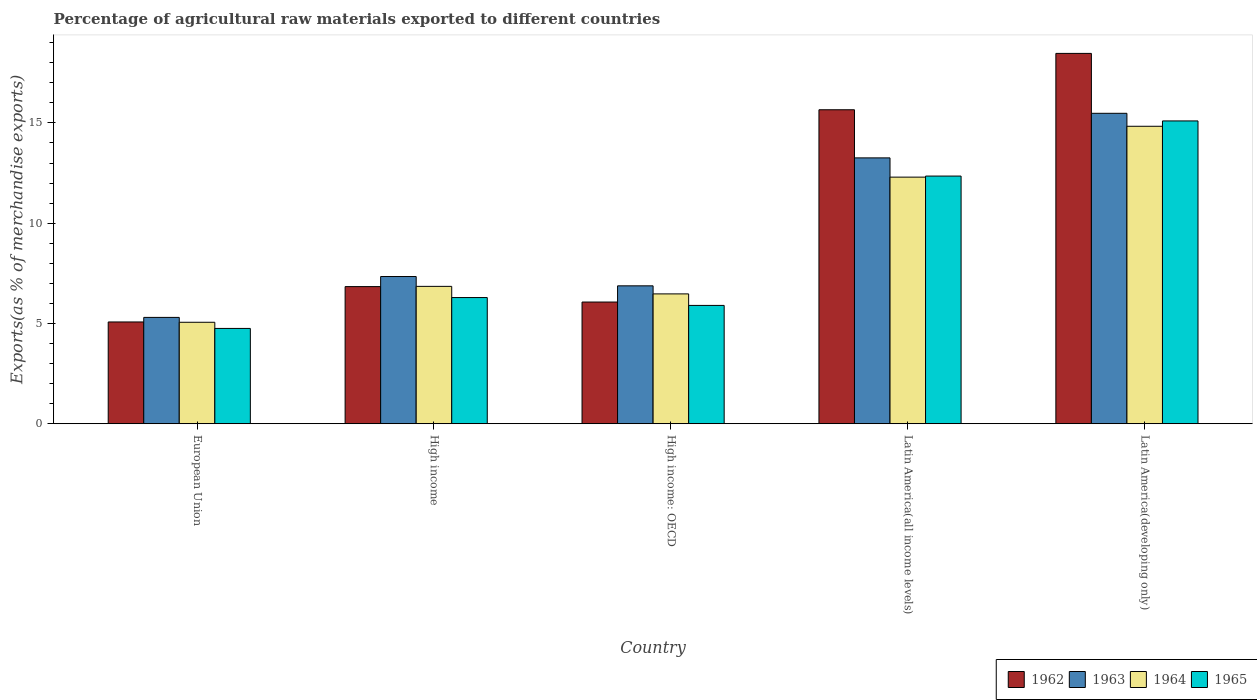How many different coloured bars are there?
Give a very brief answer. 4. Are the number of bars on each tick of the X-axis equal?
Provide a succinct answer. Yes. How many bars are there on the 3rd tick from the left?
Keep it short and to the point. 4. How many bars are there on the 5th tick from the right?
Your response must be concise. 4. What is the label of the 4th group of bars from the left?
Offer a very short reply. Latin America(all income levels). In how many cases, is the number of bars for a given country not equal to the number of legend labels?
Make the answer very short. 0. What is the percentage of exports to different countries in 1965 in European Union?
Keep it short and to the point. 4.75. Across all countries, what is the maximum percentage of exports to different countries in 1962?
Give a very brief answer. 18.47. Across all countries, what is the minimum percentage of exports to different countries in 1964?
Give a very brief answer. 5.06. In which country was the percentage of exports to different countries in 1964 maximum?
Offer a terse response. Latin America(developing only). In which country was the percentage of exports to different countries in 1965 minimum?
Your response must be concise. European Union. What is the total percentage of exports to different countries in 1964 in the graph?
Provide a short and direct response. 45.52. What is the difference between the percentage of exports to different countries in 1962 in European Union and that in Latin America(all income levels)?
Keep it short and to the point. -10.58. What is the difference between the percentage of exports to different countries in 1963 in Latin America(developing only) and the percentage of exports to different countries in 1965 in European Union?
Your answer should be very brief. 10.73. What is the average percentage of exports to different countries in 1963 per country?
Your answer should be very brief. 9.65. What is the difference between the percentage of exports to different countries of/in 1962 and percentage of exports to different countries of/in 1964 in High income?
Provide a succinct answer. -0.01. What is the ratio of the percentage of exports to different countries in 1963 in European Union to that in Latin America(all income levels)?
Provide a short and direct response. 0.4. Is the difference between the percentage of exports to different countries in 1962 in European Union and Latin America(developing only) greater than the difference between the percentage of exports to different countries in 1964 in European Union and Latin America(developing only)?
Your answer should be very brief. No. What is the difference between the highest and the second highest percentage of exports to different countries in 1965?
Ensure brevity in your answer.  6.06. What is the difference between the highest and the lowest percentage of exports to different countries in 1962?
Give a very brief answer. 13.39. In how many countries, is the percentage of exports to different countries in 1962 greater than the average percentage of exports to different countries in 1962 taken over all countries?
Ensure brevity in your answer.  2. Is the sum of the percentage of exports to different countries in 1965 in High income and Latin America(developing only) greater than the maximum percentage of exports to different countries in 1964 across all countries?
Provide a short and direct response. Yes. What does the 3rd bar from the left in High income: OECD represents?
Provide a succinct answer. 1964. What does the 2nd bar from the right in Latin America(developing only) represents?
Provide a succinct answer. 1964. How many bars are there?
Provide a short and direct response. 20. Are all the bars in the graph horizontal?
Your answer should be very brief. No. How many countries are there in the graph?
Your response must be concise. 5. Does the graph contain grids?
Your answer should be very brief. No. Where does the legend appear in the graph?
Ensure brevity in your answer.  Bottom right. What is the title of the graph?
Your answer should be very brief. Percentage of agricultural raw materials exported to different countries. What is the label or title of the Y-axis?
Give a very brief answer. Exports(as % of merchandise exports). What is the Exports(as % of merchandise exports) in 1962 in European Union?
Provide a succinct answer. 5.08. What is the Exports(as % of merchandise exports) of 1963 in European Union?
Offer a very short reply. 5.3. What is the Exports(as % of merchandise exports) in 1964 in European Union?
Provide a short and direct response. 5.06. What is the Exports(as % of merchandise exports) in 1965 in European Union?
Your answer should be very brief. 4.75. What is the Exports(as % of merchandise exports) of 1962 in High income?
Give a very brief answer. 6.84. What is the Exports(as % of merchandise exports) of 1963 in High income?
Provide a succinct answer. 7.34. What is the Exports(as % of merchandise exports) in 1964 in High income?
Keep it short and to the point. 6.85. What is the Exports(as % of merchandise exports) in 1965 in High income?
Ensure brevity in your answer.  6.29. What is the Exports(as % of merchandise exports) in 1962 in High income: OECD?
Your response must be concise. 6.07. What is the Exports(as % of merchandise exports) of 1963 in High income: OECD?
Provide a succinct answer. 6.88. What is the Exports(as % of merchandise exports) of 1964 in High income: OECD?
Make the answer very short. 6.47. What is the Exports(as % of merchandise exports) of 1965 in High income: OECD?
Offer a very short reply. 5.9. What is the Exports(as % of merchandise exports) in 1962 in Latin America(all income levels)?
Make the answer very short. 15.66. What is the Exports(as % of merchandise exports) of 1963 in Latin America(all income levels)?
Make the answer very short. 13.26. What is the Exports(as % of merchandise exports) of 1964 in Latin America(all income levels)?
Offer a very short reply. 12.3. What is the Exports(as % of merchandise exports) in 1965 in Latin America(all income levels)?
Keep it short and to the point. 12.35. What is the Exports(as % of merchandise exports) in 1962 in Latin America(developing only)?
Give a very brief answer. 18.47. What is the Exports(as % of merchandise exports) of 1963 in Latin America(developing only)?
Give a very brief answer. 15.48. What is the Exports(as % of merchandise exports) of 1964 in Latin America(developing only)?
Give a very brief answer. 14.83. What is the Exports(as % of merchandise exports) in 1965 in Latin America(developing only)?
Offer a terse response. 15.1. Across all countries, what is the maximum Exports(as % of merchandise exports) of 1962?
Make the answer very short. 18.47. Across all countries, what is the maximum Exports(as % of merchandise exports) in 1963?
Provide a succinct answer. 15.48. Across all countries, what is the maximum Exports(as % of merchandise exports) in 1964?
Your answer should be very brief. 14.83. Across all countries, what is the maximum Exports(as % of merchandise exports) in 1965?
Ensure brevity in your answer.  15.1. Across all countries, what is the minimum Exports(as % of merchandise exports) of 1962?
Give a very brief answer. 5.08. Across all countries, what is the minimum Exports(as % of merchandise exports) of 1963?
Provide a succinct answer. 5.3. Across all countries, what is the minimum Exports(as % of merchandise exports) of 1964?
Offer a terse response. 5.06. Across all countries, what is the minimum Exports(as % of merchandise exports) in 1965?
Your answer should be compact. 4.75. What is the total Exports(as % of merchandise exports) in 1962 in the graph?
Offer a very short reply. 52.11. What is the total Exports(as % of merchandise exports) of 1963 in the graph?
Provide a succinct answer. 48.26. What is the total Exports(as % of merchandise exports) of 1964 in the graph?
Your answer should be compact. 45.52. What is the total Exports(as % of merchandise exports) of 1965 in the graph?
Give a very brief answer. 44.4. What is the difference between the Exports(as % of merchandise exports) of 1962 in European Union and that in High income?
Ensure brevity in your answer.  -1.76. What is the difference between the Exports(as % of merchandise exports) of 1963 in European Union and that in High income?
Offer a very short reply. -2.04. What is the difference between the Exports(as % of merchandise exports) in 1964 in European Union and that in High income?
Your answer should be very brief. -1.79. What is the difference between the Exports(as % of merchandise exports) of 1965 in European Union and that in High income?
Give a very brief answer. -1.54. What is the difference between the Exports(as % of merchandise exports) of 1962 in European Union and that in High income: OECD?
Give a very brief answer. -0.99. What is the difference between the Exports(as % of merchandise exports) in 1963 in European Union and that in High income: OECD?
Keep it short and to the point. -1.57. What is the difference between the Exports(as % of merchandise exports) of 1964 in European Union and that in High income: OECD?
Keep it short and to the point. -1.41. What is the difference between the Exports(as % of merchandise exports) in 1965 in European Union and that in High income: OECD?
Offer a very short reply. -1.15. What is the difference between the Exports(as % of merchandise exports) of 1962 in European Union and that in Latin America(all income levels)?
Provide a short and direct response. -10.58. What is the difference between the Exports(as % of merchandise exports) in 1963 in European Union and that in Latin America(all income levels)?
Ensure brevity in your answer.  -7.95. What is the difference between the Exports(as % of merchandise exports) of 1964 in European Union and that in Latin America(all income levels)?
Provide a succinct answer. -7.24. What is the difference between the Exports(as % of merchandise exports) in 1965 in European Union and that in Latin America(all income levels)?
Give a very brief answer. -7.6. What is the difference between the Exports(as % of merchandise exports) in 1962 in European Union and that in Latin America(developing only)?
Provide a short and direct response. -13.39. What is the difference between the Exports(as % of merchandise exports) in 1963 in European Union and that in Latin America(developing only)?
Make the answer very short. -10.18. What is the difference between the Exports(as % of merchandise exports) of 1964 in European Union and that in Latin America(developing only)?
Your answer should be compact. -9.77. What is the difference between the Exports(as % of merchandise exports) of 1965 in European Union and that in Latin America(developing only)?
Make the answer very short. -10.35. What is the difference between the Exports(as % of merchandise exports) in 1962 in High income and that in High income: OECD?
Offer a terse response. 0.77. What is the difference between the Exports(as % of merchandise exports) in 1963 in High income and that in High income: OECD?
Your answer should be very brief. 0.46. What is the difference between the Exports(as % of merchandise exports) of 1964 in High income and that in High income: OECD?
Your answer should be compact. 0.38. What is the difference between the Exports(as % of merchandise exports) in 1965 in High income and that in High income: OECD?
Provide a succinct answer. 0.39. What is the difference between the Exports(as % of merchandise exports) of 1962 in High income and that in Latin America(all income levels)?
Provide a succinct answer. -8.82. What is the difference between the Exports(as % of merchandise exports) of 1963 in High income and that in Latin America(all income levels)?
Your answer should be very brief. -5.92. What is the difference between the Exports(as % of merchandise exports) of 1964 in High income and that in Latin America(all income levels)?
Offer a terse response. -5.45. What is the difference between the Exports(as % of merchandise exports) in 1965 in High income and that in Latin America(all income levels)?
Provide a succinct answer. -6.06. What is the difference between the Exports(as % of merchandise exports) of 1962 in High income and that in Latin America(developing only)?
Ensure brevity in your answer.  -11.63. What is the difference between the Exports(as % of merchandise exports) in 1963 in High income and that in Latin America(developing only)?
Provide a short and direct response. -8.14. What is the difference between the Exports(as % of merchandise exports) of 1964 in High income and that in Latin America(developing only)?
Your answer should be very brief. -7.98. What is the difference between the Exports(as % of merchandise exports) in 1965 in High income and that in Latin America(developing only)?
Ensure brevity in your answer.  -8.81. What is the difference between the Exports(as % of merchandise exports) of 1962 in High income: OECD and that in Latin America(all income levels)?
Offer a very short reply. -9.59. What is the difference between the Exports(as % of merchandise exports) in 1963 in High income: OECD and that in Latin America(all income levels)?
Make the answer very short. -6.38. What is the difference between the Exports(as % of merchandise exports) of 1964 in High income: OECD and that in Latin America(all income levels)?
Give a very brief answer. -5.82. What is the difference between the Exports(as % of merchandise exports) in 1965 in High income: OECD and that in Latin America(all income levels)?
Your answer should be compact. -6.45. What is the difference between the Exports(as % of merchandise exports) of 1962 in High income: OECD and that in Latin America(developing only)?
Your answer should be compact. -12.4. What is the difference between the Exports(as % of merchandise exports) of 1963 in High income: OECD and that in Latin America(developing only)?
Give a very brief answer. -8.6. What is the difference between the Exports(as % of merchandise exports) in 1964 in High income: OECD and that in Latin America(developing only)?
Give a very brief answer. -8.36. What is the difference between the Exports(as % of merchandise exports) of 1965 in High income: OECD and that in Latin America(developing only)?
Keep it short and to the point. -9.2. What is the difference between the Exports(as % of merchandise exports) of 1962 in Latin America(all income levels) and that in Latin America(developing only)?
Keep it short and to the point. -2.81. What is the difference between the Exports(as % of merchandise exports) in 1963 in Latin America(all income levels) and that in Latin America(developing only)?
Your answer should be compact. -2.22. What is the difference between the Exports(as % of merchandise exports) of 1964 in Latin America(all income levels) and that in Latin America(developing only)?
Offer a terse response. -2.54. What is the difference between the Exports(as % of merchandise exports) in 1965 in Latin America(all income levels) and that in Latin America(developing only)?
Provide a succinct answer. -2.75. What is the difference between the Exports(as % of merchandise exports) in 1962 in European Union and the Exports(as % of merchandise exports) in 1963 in High income?
Provide a short and direct response. -2.27. What is the difference between the Exports(as % of merchandise exports) of 1962 in European Union and the Exports(as % of merchandise exports) of 1964 in High income?
Your response must be concise. -1.78. What is the difference between the Exports(as % of merchandise exports) of 1962 in European Union and the Exports(as % of merchandise exports) of 1965 in High income?
Your response must be concise. -1.22. What is the difference between the Exports(as % of merchandise exports) in 1963 in European Union and the Exports(as % of merchandise exports) in 1964 in High income?
Provide a succinct answer. -1.55. What is the difference between the Exports(as % of merchandise exports) of 1963 in European Union and the Exports(as % of merchandise exports) of 1965 in High income?
Offer a terse response. -0.99. What is the difference between the Exports(as % of merchandise exports) of 1964 in European Union and the Exports(as % of merchandise exports) of 1965 in High income?
Give a very brief answer. -1.23. What is the difference between the Exports(as % of merchandise exports) of 1962 in European Union and the Exports(as % of merchandise exports) of 1963 in High income: OECD?
Your answer should be very brief. -1.8. What is the difference between the Exports(as % of merchandise exports) of 1962 in European Union and the Exports(as % of merchandise exports) of 1964 in High income: OECD?
Your response must be concise. -1.4. What is the difference between the Exports(as % of merchandise exports) in 1962 in European Union and the Exports(as % of merchandise exports) in 1965 in High income: OECD?
Make the answer very short. -0.83. What is the difference between the Exports(as % of merchandise exports) of 1963 in European Union and the Exports(as % of merchandise exports) of 1964 in High income: OECD?
Your response must be concise. -1.17. What is the difference between the Exports(as % of merchandise exports) in 1963 in European Union and the Exports(as % of merchandise exports) in 1965 in High income: OECD?
Ensure brevity in your answer.  -0.6. What is the difference between the Exports(as % of merchandise exports) in 1964 in European Union and the Exports(as % of merchandise exports) in 1965 in High income: OECD?
Your answer should be very brief. -0.84. What is the difference between the Exports(as % of merchandise exports) in 1962 in European Union and the Exports(as % of merchandise exports) in 1963 in Latin America(all income levels)?
Your response must be concise. -8.18. What is the difference between the Exports(as % of merchandise exports) of 1962 in European Union and the Exports(as % of merchandise exports) of 1964 in Latin America(all income levels)?
Offer a very short reply. -7.22. What is the difference between the Exports(as % of merchandise exports) of 1962 in European Union and the Exports(as % of merchandise exports) of 1965 in Latin America(all income levels)?
Make the answer very short. -7.28. What is the difference between the Exports(as % of merchandise exports) of 1963 in European Union and the Exports(as % of merchandise exports) of 1964 in Latin America(all income levels)?
Offer a terse response. -7. What is the difference between the Exports(as % of merchandise exports) in 1963 in European Union and the Exports(as % of merchandise exports) in 1965 in Latin America(all income levels)?
Give a very brief answer. -7.05. What is the difference between the Exports(as % of merchandise exports) in 1964 in European Union and the Exports(as % of merchandise exports) in 1965 in Latin America(all income levels)?
Provide a short and direct response. -7.29. What is the difference between the Exports(as % of merchandise exports) in 1962 in European Union and the Exports(as % of merchandise exports) in 1963 in Latin America(developing only)?
Ensure brevity in your answer.  -10.41. What is the difference between the Exports(as % of merchandise exports) of 1962 in European Union and the Exports(as % of merchandise exports) of 1964 in Latin America(developing only)?
Make the answer very short. -9.76. What is the difference between the Exports(as % of merchandise exports) in 1962 in European Union and the Exports(as % of merchandise exports) in 1965 in Latin America(developing only)?
Offer a terse response. -10.02. What is the difference between the Exports(as % of merchandise exports) of 1963 in European Union and the Exports(as % of merchandise exports) of 1964 in Latin America(developing only)?
Provide a succinct answer. -9.53. What is the difference between the Exports(as % of merchandise exports) in 1963 in European Union and the Exports(as % of merchandise exports) in 1965 in Latin America(developing only)?
Offer a terse response. -9.8. What is the difference between the Exports(as % of merchandise exports) of 1964 in European Union and the Exports(as % of merchandise exports) of 1965 in Latin America(developing only)?
Provide a succinct answer. -10.04. What is the difference between the Exports(as % of merchandise exports) in 1962 in High income and the Exports(as % of merchandise exports) in 1963 in High income: OECD?
Give a very brief answer. -0.04. What is the difference between the Exports(as % of merchandise exports) of 1962 in High income and the Exports(as % of merchandise exports) of 1964 in High income: OECD?
Your answer should be compact. 0.36. What is the difference between the Exports(as % of merchandise exports) of 1962 in High income and the Exports(as % of merchandise exports) of 1965 in High income: OECD?
Offer a terse response. 0.94. What is the difference between the Exports(as % of merchandise exports) of 1963 in High income and the Exports(as % of merchandise exports) of 1964 in High income: OECD?
Offer a very short reply. 0.87. What is the difference between the Exports(as % of merchandise exports) of 1963 in High income and the Exports(as % of merchandise exports) of 1965 in High income: OECD?
Provide a short and direct response. 1.44. What is the difference between the Exports(as % of merchandise exports) of 1964 in High income and the Exports(as % of merchandise exports) of 1965 in High income: OECD?
Your response must be concise. 0.95. What is the difference between the Exports(as % of merchandise exports) of 1962 in High income and the Exports(as % of merchandise exports) of 1963 in Latin America(all income levels)?
Make the answer very short. -6.42. What is the difference between the Exports(as % of merchandise exports) in 1962 in High income and the Exports(as % of merchandise exports) in 1964 in Latin America(all income levels)?
Give a very brief answer. -5.46. What is the difference between the Exports(as % of merchandise exports) in 1962 in High income and the Exports(as % of merchandise exports) in 1965 in Latin America(all income levels)?
Provide a short and direct response. -5.51. What is the difference between the Exports(as % of merchandise exports) of 1963 in High income and the Exports(as % of merchandise exports) of 1964 in Latin America(all income levels)?
Make the answer very short. -4.96. What is the difference between the Exports(as % of merchandise exports) of 1963 in High income and the Exports(as % of merchandise exports) of 1965 in Latin America(all income levels)?
Ensure brevity in your answer.  -5.01. What is the difference between the Exports(as % of merchandise exports) in 1962 in High income and the Exports(as % of merchandise exports) in 1963 in Latin America(developing only)?
Ensure brevity in your answer.  -8.64. What is the difference between the Exports(as % of merchandise exports) of 1962 in High income and the Exports(as % of merchandise exports) of 1964 in Latin America(developing only)?
Make the answer very short. -8. What is the difference between the Exports(as % of merchandise exports) in 1962 in High income and the Exports(as % of merchandise exports) in 1965 in Latin America(developing only)?
Your answer should be very brief. -8.26. What is the difference between the Exports(as % of merchandise exports) of 1963 in High income and the Exports(as % of merchandise exports) of 1964 in Latin America(developing only)?
Your answer should be compact. -7.49. What is the difference between the Exports(as % of merchandise exports) of 1963 in High income and the Exports(as % of merchandise exports) of 1965 in Latin America(developing only)?
Provide a succinct answer. -7.76. What is the difference between the Exports(as % of merchandise exports) in 1964 in High income and the Exports(as % of merchandise exports) in 1965 in Latin America(developing only)?
Ensure brevity in your answer.  -8.25. What is the difference between the Exports(as % of merchandise exports) in 1962 in High income: OECD and the Exports(as % of merchandise exports) in 1963 in Latin America(all income levels)?
Offer a very short reply. -7.19. What is the difference between the Exports(as % of merchandise exports) in 1962 in High income: OECD and the Exports(as % of merchandise exports) in 1964 in Latin America(all income levels)?
Provide a succinct answer. -6.23. What is the difference between the Exports(as % of merchandise exports) of 1962 in High income: OECD and the Exports(as % of merchandise exports) of 1965 in Latin America(all income levels)?
Your response must be concise. -6.28. What is the difference between the Exports(as % of merchandise exports) of 1963 in High income: OECD and the Exports(as % of merchandise exports) of 1964 in Latin America(all income levels)?
Provide a succinct answer. -5.42. What is the difference between the Exports(as % of merchandise exports) in 1963 in High income: OECD and the Exports(as % of merchandise exports) in 1965 in Latin America(all income levels)?
Ensure brevity in your answer.  -5.47. What is the difference between the Exports(as % of merchandise exports) in 1964 in High income: OECD and the Exports(as % of merchandise exports) in 1965 in Latin America(all income levels)?
Your answer should be very brief. -5.88. What is the difference between the Exports(as % of merchandise exports) of 1962 in High income: OECD and the Exports(as % of merchandise exports) of 1963 in Latin America(developing only)?
Offer a very short reply. -9.41. What is the difference between the Exports(as % of merchandise exports) of 1962 in High income: OECD and the Exports(as % of merchandise exports) of 1964 in Latin America(developing only)?
Ensure brevity in your answer.  -8.76. What is the difference between the Exports(as % of merchandise exports) of 1962 in High income: OECD and the Exports(as % of merchandise exports) of 1965 in Latin America(developing only)?
Your response must be concise. -9.03. What is the difference between the Exports(as % of merchandise exports) in 1963 in High income: OECD and the Exports(as % of merchandise exports) in 1964 in Latin America(developing only)?
Your answer should be very brief. -7.96. What is the difference between the Exports(as % of merchandise exports) of 1963 in High income: OECD and the Exports(as % of merchandise exports) of 1965 in Latin America(developing only)?
Your answer should be compact. -8.22. What is the difference between the Exports(as % of merchandise exports) of 1964 in High income: OECD and the Exports(as % of merchandise exports) of 1965 in Latin America(developing only)?
Keep it short and to the point. -8.63. What is the difference between the Exports(as % of merchandise exports) of 1962 in Latin America(all income levels) and the Exports(as % of merchandise exports) of 1963 in Latin America(developing only)?
Provide a succinct answer. 0.18. What is the difference between the Exports(as % of merchandise exports) in 1962 in Latin America(all income levels) and the Exports(as % of merchandise exports) in 1964 in Latin America(developing only)?
Make the answer very short. 0.82. What is the difference between the Exports(as % of merchandise exports) of 1962 in Latin America(all income levels) and the Exports(as % of merchandise exports) of 1965 in Latin America(developing only)?
Your answer should be compact. 0.56. What is the difference between the Exports(as % of merchandise exports) of 1963 in Latin America(all income levels) and the Exports(as % of merchandise exports) of 1964 in Latin America(developing only)?
Make the answer very short. -1.58. What is the difference between the Exports(as % of merchandise exports) in 1963 in Latin America(all income levels) and the Exports(as % of merchandise exports) in 1965 in Latin America(developing only)?
Your answer should be very brief. -1.84. What is the difference between the Exports(as % of merchandise exports) of 1964 in Latin America(all income levels) and the Exports(as % of merchandise exports) of 1965 in Latin America(developing only)?
Offer a terse response. -2.8. What is the average Exports(as % of merchandise exports) of 1962 per country?
Offer a very short reply. 10.42. What is the average Exports(as % of merchandise exports) of 1963 per country?
Provide a succinct answer. 9.65. What is the average Exports(as % of merchandise exports) in 1964 per country?
Provide a short and direct response. 9.1. What is the average Exports(as % of merchandise exports) of 1965 per country?
Ensure brevity in your answer.  8.88. What is the difference between the Exports(as % of merchandise exports) of 1962 and Exports(as % of merchandise exports) of 1963 in European Union?
Offer a very short reply. -0.23. What is the difference between the Exports(as % of merchandise exports) of 1962 and Exports(as % of merchandise exports) of 1964 in European Union?
Ensure brevity in your answer.  0.02. What is the difference between the Exports(as % of merchandise exports) in 1962 and Exports(as % of merchandise exports) in 1965 in European Union?
Your answer should be compact. 0.32. What is the difference between the Exports(as % of merchandise exports) in 1963 and Exports(as % of merchandise exports) in 1964 in European Union?
Ensure brevity in your answer.  0.24. What is the difference between the Exports(as % of merchandise exports) in 1963 and Exports(as % of merchandise exports) in 1965 in European Union?
Give a very brief answer. 0.55. What is the difference between the Exports(as % of merchandise exports) of 1964 and Exports(as % of merchandise exports) of 1965 in European Union?
Your answer should be very brief. 0.31. What is the difference between the Exports(as % of merchandise exports) in 1962 and Exports(as % of merchandise exports) in 1963 in High income?
Your answer should be compact. -0.5. What is the difference between the Exports(as % of merchandise exports) in 1962 and Exports(as % of merchandise exports) in 1964 in High income?
Keep it short and to the point. -0.01. What is the difference between the Exports(as % of merchandise exports) of 1962 and Exports(as % of merchandise exports) of 1965 in High income?
Ensure brevity in your answer.  0.55. What is the difference between the Exports(as % of merchandise exports) in 1963 and Exports(as % of merchandise exports) in 1964 in High income?
Offer a very short reply. 0.49. What is the difference between the Exports(as % of merchandise exports) in 1963 and Exports(as % of merchandise exports) in 1965 in High income?
Keep it short and to the point. 1.05. What is the difference between the Exports(as % of merchandise exports) of 1964 and Exports(as % of merchandise exports) of 1965 in High income?
Keep it short and to the point. 0.56. What is the difference between the Exports(as % of merchandise exports) of 1962 and Exports(as % of merchandise exports) of 1963 in High income: OECD?
Provide a succinct answer. -0.81. What is the difference between the Exports(as % of merchandise exports) in 1962 and Exports(as % of merchandise exports) in 1964 in High income: OECD?
Your answer should be compact. -0.41. What is the difference between the Exports(as % of merchandise exports) in 1962 and Exports(as % of merchandise exports) in 1965 in High income: OECD?
Offer a very short reply. 0.17. What is the difference between the Exports(as % of merchandise exports) of 1963 and Exports(as % of merchandise exports) of 1964 in High income: OECD?
Your answer should be very brief. 0.4. What is the difference between the Exports(as % of merchandise exports) of 1963 and Exports(as % of merchandise exports) of 1965 in High income: OECD?
Offer a very short reply. 0.98. What is the difference between the Exports(as % of merchandise exports) in 1964 and Exports(as % of merchandise exports) in 1965 in High income: OECD?
Keep it short and to the point. 0.57. What is the difference between the Exports(as % of merchandise exports) in 1962 and Exports(as % of merchandise exports) in 1963 in Latin America(all income levels)?
Provide a succinct answer. 2.4. What is the difference between the Exports(as % of merchandise exports) of 1962 and Exports(as % of merchandise exports) of 1964 in Latin America(all income levels)?
Offer a terse response. 3.36. What is the difference between the Exports(as % of merchandise exports) in 1962 and Exports(as % of merchandise exports) in 1965 in Latin America(all income levels)?
Ensure brevity in your answer.  3.31. What is the difference between the Exports(as % of merchandise exports) in 1963 and Exports(as % of merchandise exports) in 1964 in Latin America(all income levels)?
Make the answer very short. 0.96. What is the difference between the Exports(as % of merchandise exports) of 1963 and Exports(as % of merchandise exports) of 1965 in Latin America(all income levels)?
Provide a short and direct response. 0.91. What is the difference between the Exports(as % of merchandise exports) in 1964 and Exports(as % of merchandise exports) in 1965 in Latin America(all income levels)?
Your response must be concise. -0.05. What is the difference between the Exports(as % of merchandise exports) in 1962 and Exports(as % of merchandise exports) in 1963 in Latin America(developing only)?
Your answer should be very brief. 2.99. What is the difference between the Exports(as % of merchandise exports) in 1962 and Exports(as % of merchandise exports) in 1964 in Latin America(developing only)?
Your answer should be very brief. 3.63. What is the difference between the Exports(as % of merchandise exports) of 1962 and Exports(as % of merchandise exports) of 1965 in Latin America(developing only)?
Provide a succinct answer. 3.37. What is the difference between the Exports(as % of merchandise exports) in 1963 and Exports(as % of merchandise exports) in 1964 in Latin America(developing only)?
Your response must be concise. 0.65. What is the difference between the Exports(as % of merchandise exports) in 1963 and Exports(as % of merchandise exports) in 1965 in Latin America(developing only)?
Offer a very short reply. 0.38. What is the difference between the Exports(as % of merchandise exports) in 1964 and Exports(as % of merchandise exports) in 1965 in Latin America(developing only)?
Your answer should be compact. -0.27. What is the ratio of the Exports(as % of merchandise exports) in 1962 in European Union to that in High income?
Give a very brief answer. 0.74. What is the ratio of the Exports(as % of merchandise exports) in 1963 in European Union to that in High income?
Provide a succinct answer. 0.72. What is the ratio of the Exports(as % of merchandise exports) of 1964 in European Union to that in High income?
Your answer should be very brief. 0.74. What is the ratio of the Exports(as % of merchandise exports) of 1965 in European Union to that in High income?
Your answer should be very brief. 0.76. What is the ratio of the Exports(as % of merchandise exports) of 1962 in European Union to that in High income: OECD?
Offer a terse response. 0.84. What is the ratio of the Exports(as % of merchandise exports) in 1963 in European Union to that in High income: OECD?
Give a very brief answer. 0.77. What is the ratio of the Exports(as % of merchandise exports) of 1964 in European Union to that in High income: OECD?
Your answer should be very brief. 0.78. What is the ratio of the Exports(as % of merchandise exports) in 1965 in European Union to that in High income: OECD?
Ensure brevity in your answer.  0.81. What is the ratio of the Exports(as % of merchandise exports) in 1962 in European Union to that in Latin America(all income levels)?
Your response must be concise. 0.32. What is the ratio of the Exports(as % of merchandise exports) of 1963 in European Union to that in Latin America(all income levels)?
Offer a very short reply. 0.4. What is the ratio of the Exports(as % of merchandise exports) of 1964 in European Union to that in Latin America(all income levels)?
Offer a terse response. 0.41. What is the ratio of the Exports(as % of merchandise exports) of 1965 in European Union to that in Latin America(all income levels)?
Your answer should be very brief. 0.38. What is the ratio of the Exports(as % of merchandise exports) of 1962 in European Union to that in Latin America(developing only)?
Your answer should be very brief. 0.27. What is the ratio of the Exports(as % of merchandise exports) of 1963 in European Union to that in Latin America(developing only)?
Provide a succinct answer. 0.34. What is the ratio of the Exports(as % of merchandise exports) in 1964 in European Union to that in Latin America(developing only)?
Give a very brief answer. 0.34. What is the ratio of the Exports(as % of merchandise exports) in 1965 in European Union to that in Latin America(developing only)?
Ensure brevity in your answer.  0.31. What is the ratio of the Exports(as % of merchandise exports) of 1962 in High income to that in High income: OECD?
Make the answer very short. 1.13. What is the ratio of the Exports(as % of merchandise exports) in 1963 in High income to that in High income: OECD?
Keep it short and to the point. 1.07. What is the ratio of the Exports(as % of merchandise exports) in 1964 in High income to that in High income: OECD?
Provide a succinct answer. 1.06. What is the ratio of the Exports(as % of merchandise exports) of 1965 in High income to that in High income: OECD?
Your response must be concise. 1.07. What is the ratio of the Exports(as % of merchandise exports) in 1962 in High income to that in Latin America(all income levels)?
Make the answer very short. 0.44. What is the ratio of the Exports(as % of merchandise exports) in 1963 in High income to that in Latin America(all income levels)?
Offer a very short reply. 0.55. What is the ratio of the Exports(as % of merchandise exports) of 1964 in High income to that in Latin America(all income levels)?
Your answer should be very brief. 0.56. What is the ratio of the Exports(as % of merchandise exports) of 1965 in High income to that in Latin America(all income levels)?
Ensure brevity in your answer.  0.51. What is the ratio of the Exports(as % of merchandise exports) of 1962 in High income to that in Latin America(developing only)?
Provide a succinct answer. 0.37. What is the ratio of the Exports(as % of merchandise exports) in 1963 in High income to that in Latin America(developing only)?
Provide a succinct answer. 0.47. What is the ratio of the Exports(as % of merchandise exports) in 1964 in High income to that in Latin America(developing only)?
Your answer should be very brief. 0.46. What is the ratio of the Exports(as % of merchandise exports) of 1965 in High income to that in Latin America(developing only)?
Keep it short and to the point. 0.42. What is the ratio of the Exports(as % of merchandise exports) in 1962 in High income: OECD to that in Latin America(all income levels)?
Provide a short and direct response. 0.39. What is the ratio of the Exports(as % of merchandise exports) in 1963 in High income: OECD to that in Latin America(all income levels)?
Provide a succinct answer. 0.52. What is the ratio of the Exports(as % of merchandise exports) in 1964 in High income: OECD to that in Latin America(all income levels)?
Make the answer very short. 0.53. What is the ratio of the Exports(as % of merchandise exports) in 1965 in High income: OECD to that in Latin America(all income levels)?
Provide a short and direct response. 0.48. What is the ratio of the Exports(as % of merchandise exports) in 1962 in High income: OECD to that in Latin America(developing only)?
Offer a terse response. 0.33. What is the ratio of the Exports(as % of merchandise exports) of 1963 in High income: OECD to that in Latin America(developing only)?
Ensure brevity in your answer.  0.44. What is the ratio of the Exports(as % of merchandise exports) in 1964 in High income: OECD to that in Latin America(developing only)?
Your answer should be very brief. 0.44. What is the ratio of the Exports(as % of merchandise exports) of 1965 in High income: OECD to that in Latin America(developing only)?
Make the answer very short. 0.39. What is the ratio of the Exports(as % of merchandise exports) in 1962 in Latin America(all income levels) to that in Latin America(developing only)?
Make the answer very short. 0.85. What is the ratio of the Exports(as % of merchandise exports) of 1963 in Latin America(all income levels) to that in Latin America(developing only)?
Offer a very short reply. 0.86. What is the ratio of the Exports(as % of merchandise exports) in 1964 in Latin America(all income levels) to that in Latin America(developing only)?
Your response must be concise. 0.83. What is the ratio of the Exports(as % of merchandise exports) of 1965 in Latin America(all income levels) to that in Latin America(developing only)?
Your answer should be very brief. 0.82. What is the difference between the highest and the second highest Exports(as % of merchandise exports) of 1962?
Your answer should be compact. 2.81. What is the difference between the highest and the second highest Exports(as % of merchandise exports) in 1963?
Keep it short and to the point. 2.22. What is the difference between the highest and the second highest Exports(as % of merchandise exports) of 1964?
Give a very brief answer. 2.54. What is the difference between the highest and the second highest Exports(as % of merchandise exports) in 1965?
Keep it short and to the point. 2.75. What is the difference between the highest and the lowest Exports(as % of merchandise exports) of 1962?
Provide a short and direct response. 13.39. What is the difference between the highest and the lowest Exports(as % of merchandise exports) of 1963?
Your response must be concise. 10.18. What is the difference between the highest and the lowest Exports(as % of merchandise exports) in 1964?
Your response must be concise. 9.77. What is the difference between the highest and the lowest Exports(as % of merchandise exports) of 1965?
Ensure brevity in your answer.  10.35. 